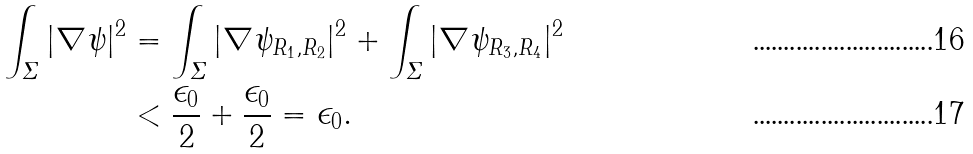Convert formula to latex. <formula><loc_0><loc_0><loc_500><loc_500>\int _ { \varSigma } | \nabla \psi | ^ { 2 } & = \int _ { \varSigma } | \nabla \psi _ { R _ { 1 } , R _ { 2 } } | ^ { 2 } + \int _ { \varSigma } | \nabla \psi _ { R _ { 3 } , R _ { 4 } } | ^ { 2 } \\ & < \frac { \epsilon _ { 0 } } { 2 } + \frac { \epsilon _ { 0 } } { 2 } = \epsilon _ { 0 } .</formula> 